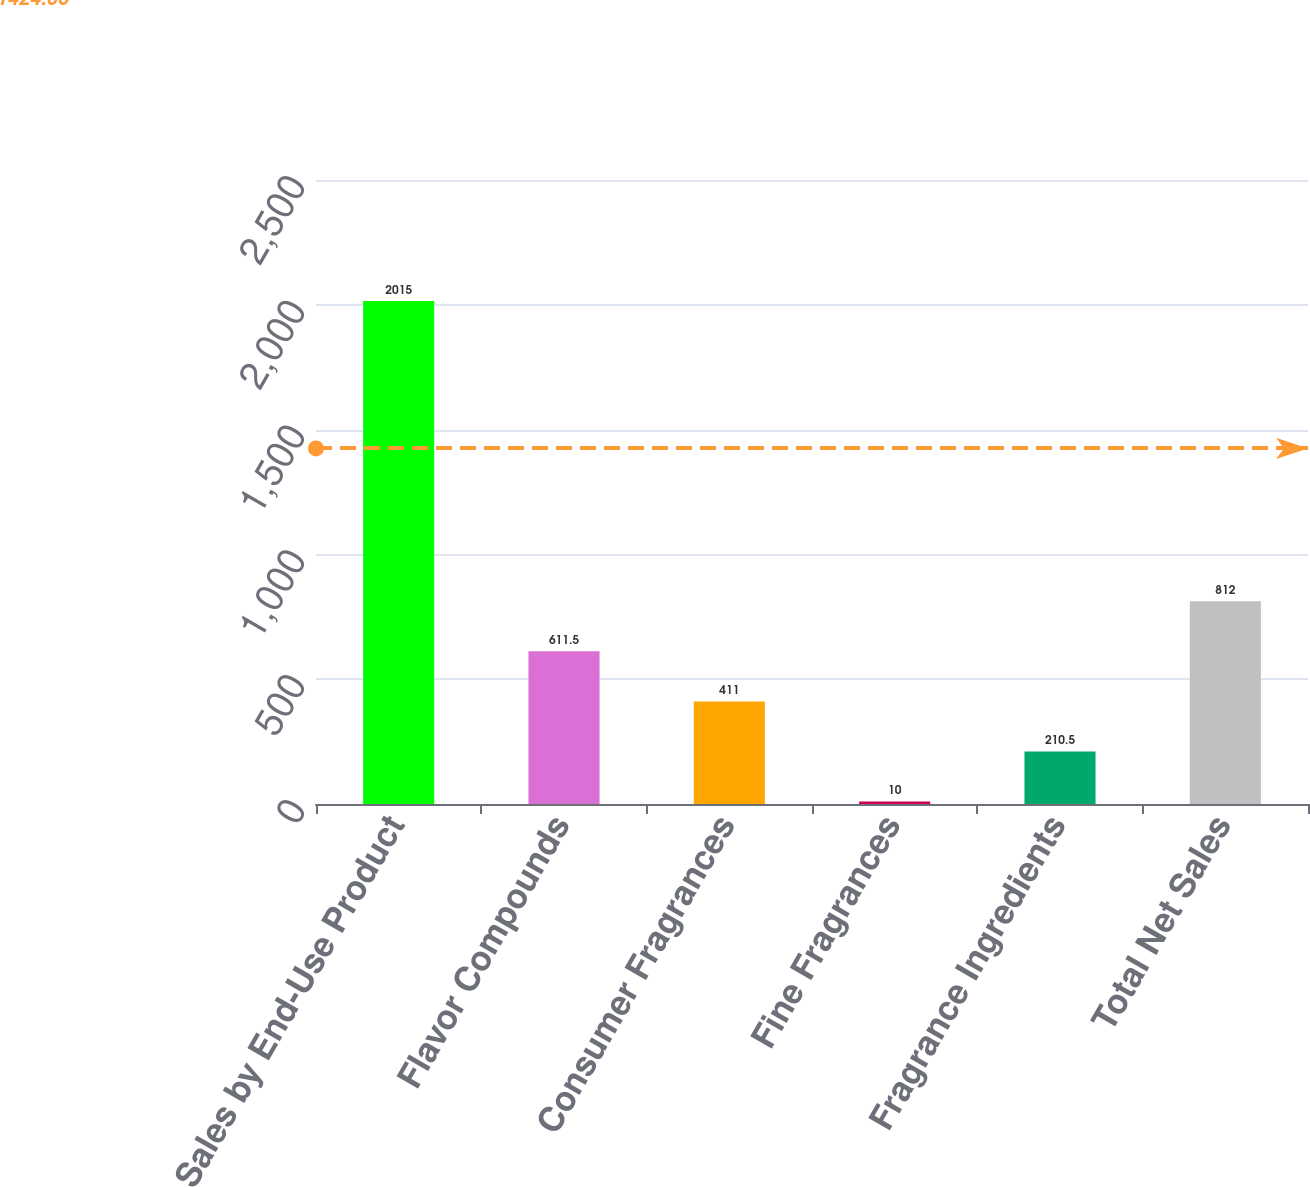Convert chart to OTSL. <chart><loc_0><loc_0><loc_500><loc_500><bar_chart><fcel>Sales by End-Use Product<fcel>Flavor Compounds<fcel>Consumer Fragrances<fcel>Fine Fragrances<fcel>Fragrance Ingredients<fcel>Total Net Sales<nl><fcel>2015<fcel>611.5<fcel>411<fcel>10<fcel>210.5<fcel>812<nl></chart> 